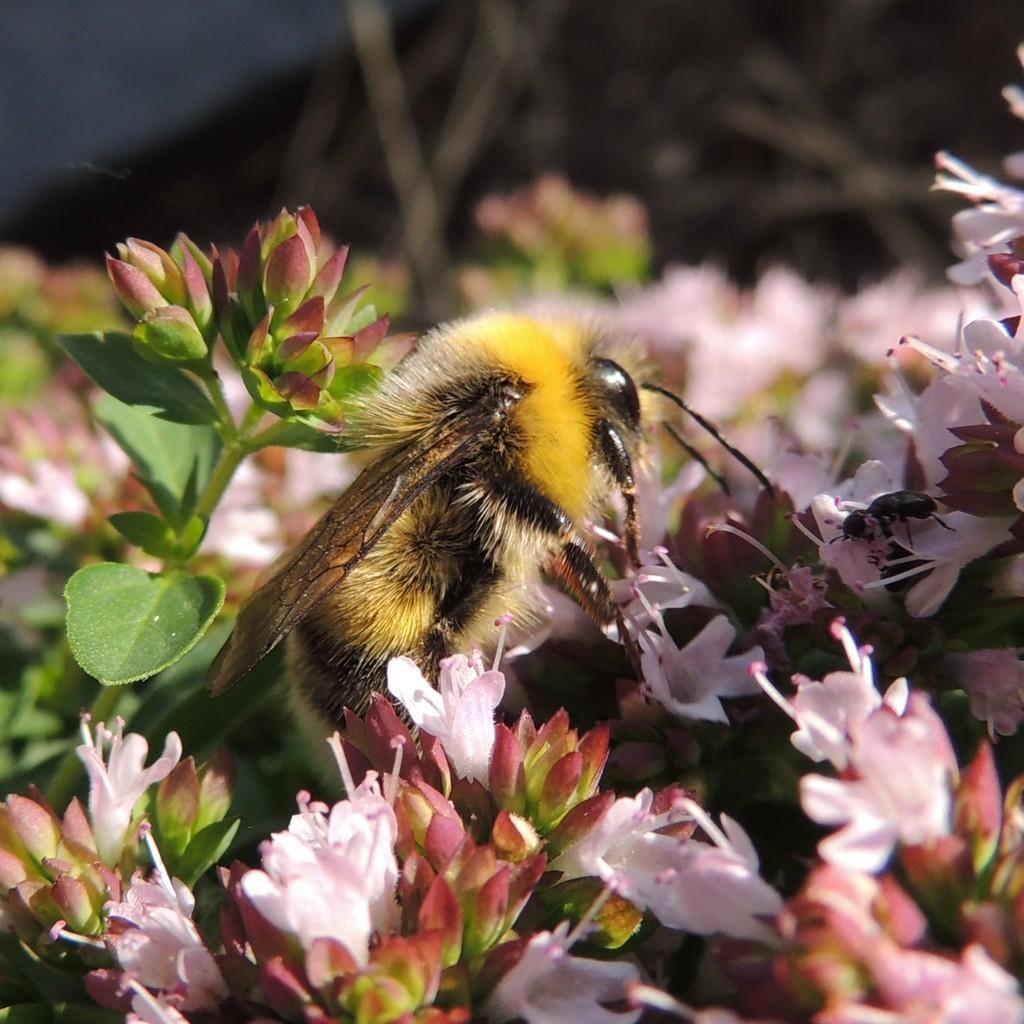Describe this image in one or two sentences. Here we can see insects, flowers, buds, and leaves. There is a blur background. 